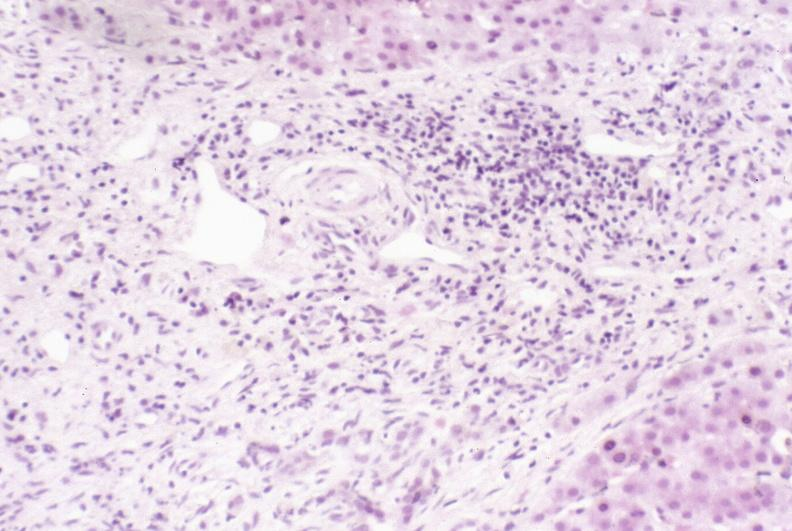s hepatobiliary present?
Answer the question using a single word or phrase. Yes 